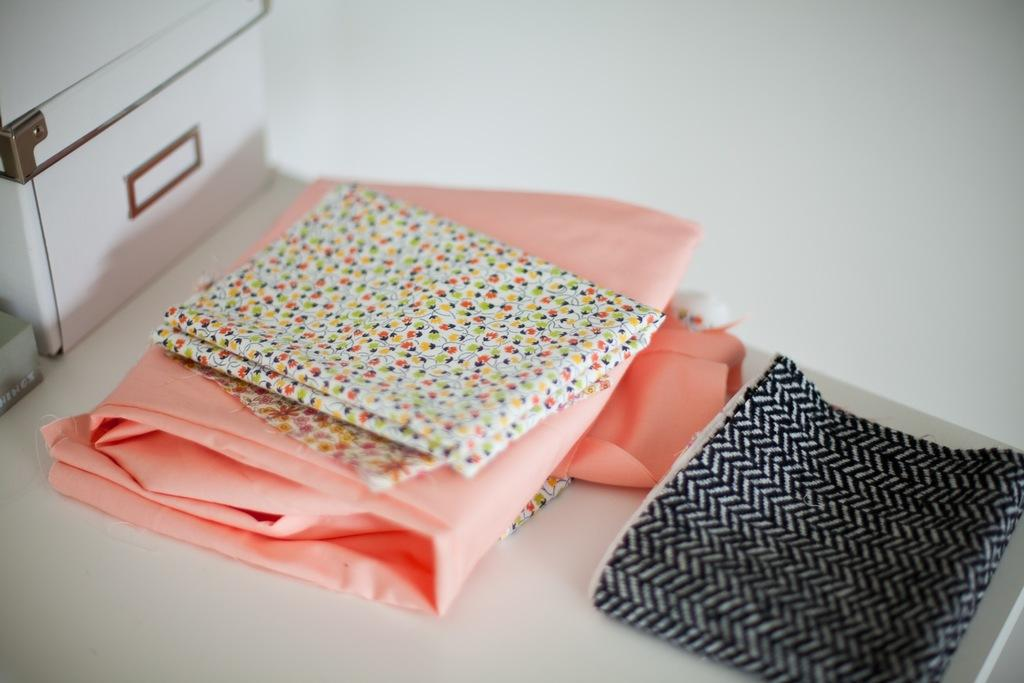What items are on the table in the image? There are clothes and boxes on the table in the image. Can you describe the background of the image? There is a wall behind the table in the image. What type of bear can be seen sitting on the table in the image? There is no bear present on the table in the image. What time of day is it in the image, considering the presence of afternoon light? There is no reference to time of day or light in the image, so it cannot be determined from the picture. 